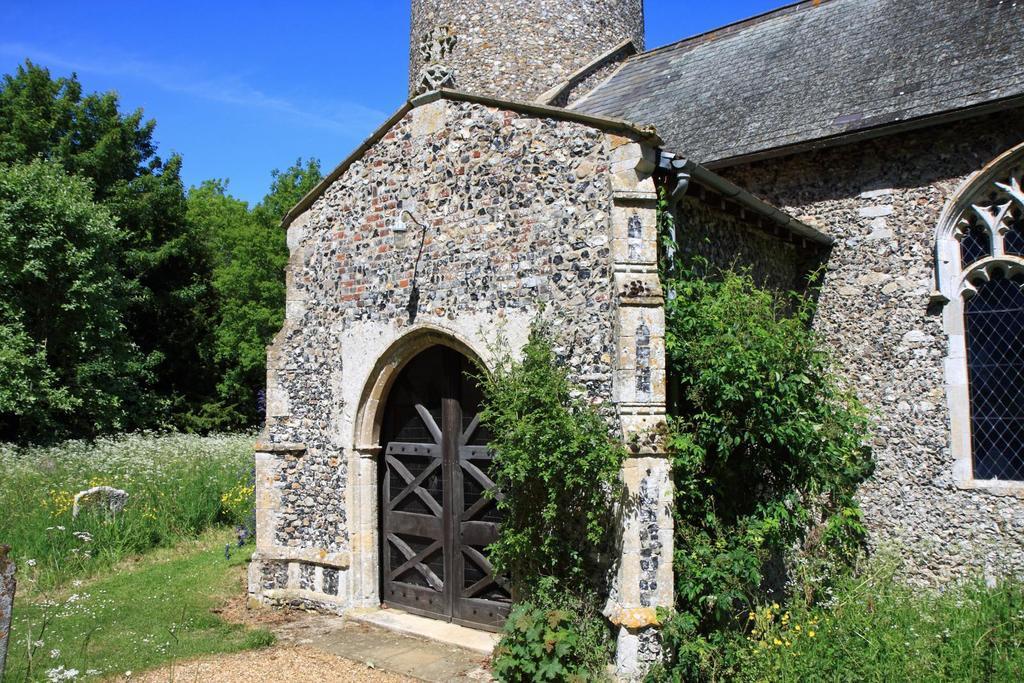Could you give a brief overview of what you see in this image? In this image there is a building on the right side of this image and there are some plants on the bottom right side of this image and the bottom left side of this image as well. There are some trees on the left side of this image and there is a sky on the top of this image. 